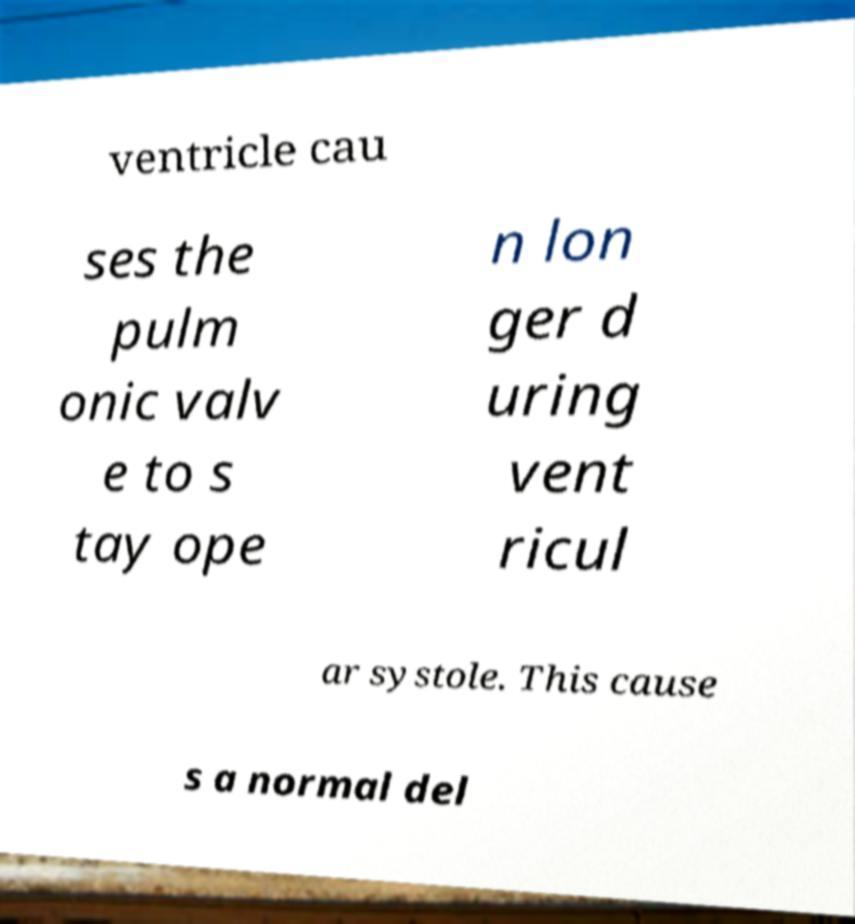Can you read and provide the text displayed in the image?This photo seems to have some interesting text. Can you extract and type it out for me? ventricle cau ses the pulm onic valv e to s tay ope n lon ger d uring vent ricul ar systole. This cause s a normal del 